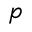<formula> <loc_0><loc_0><loc_500><loc_500>p</formula> 